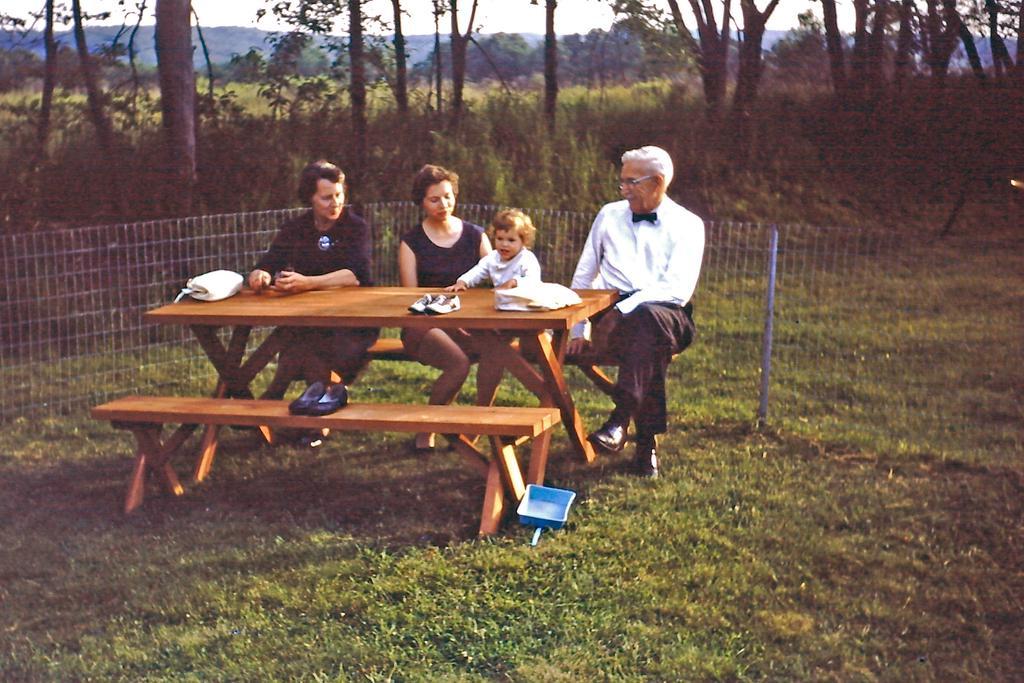How would you summarize this image in a sentence or two? In this picture we can see four persons sitting on the bench. And this is the table, on the table there is a bag, shoe. And this is the grass. Here we can see a fence. On the background we can see some trees. And this is the sky. 